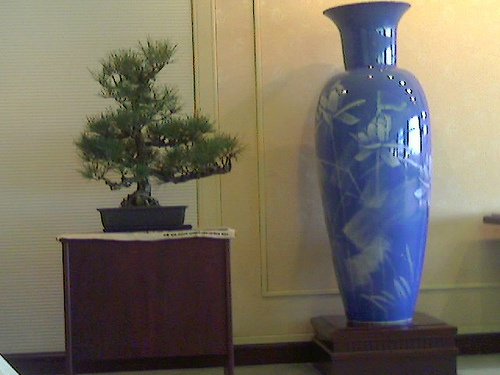Describe the objects in this image and their specific colors. I can see vase in darkgray, gray, navy, and darkblue tones, potted plant in darkgray, black, darkgreen, gray, and olive tones, and vase in darkgray, black, and gray tones in this image. 